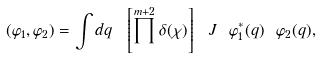Convert formula to latex. <formula><loc_0><loc_0><loc_500><loc_500>( \varphi _ { 1 } , \varphi _ { 2 } ) = \int d q \ \left [ \prod ^ { m + 2 } \delta ( \chi ) \right ] \ J \ \varphi ^ { * } _ { 1 } ( q ) \ \varphi _ { 2 } ( q ) ,</formula> 